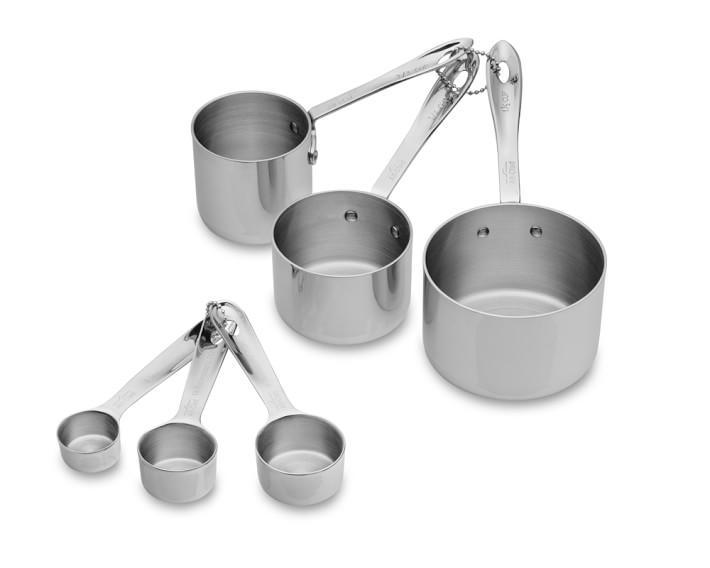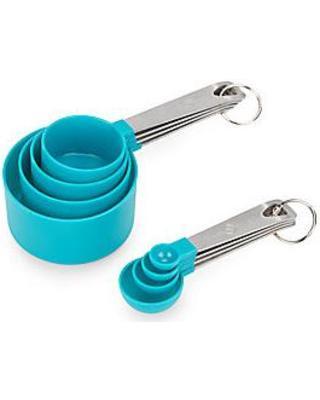The first image is the image on the left, the second image is the image on the right. For the images shown, is this caption "An image features measuring utensils with blue coloring." true? Answer yes or no. Yes. 